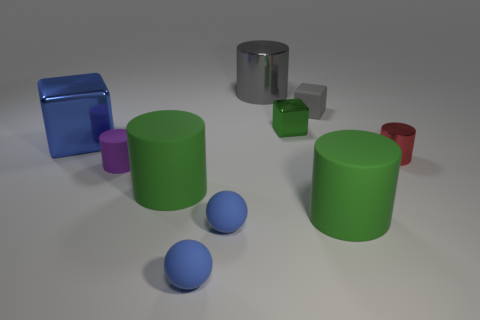Is there a large cylinder made of the same material as the tiny gray block?
Give a very brief answer. Yes. What number of objects are to the left of the red cylinder and in front of the large block?
Offer a terse response. 5. There is a tiny cylinder left of the red metal cylinder; what is its material?
Provide a succinct answer. Rubber. What is the size of the green block that is the same material as the large blue cube?
Offer a very short reply. Small. There is a blue block; are there any small blocks behind it?
Your response must be concise. Yes. What size is the other shiny thing that is the same shape as the small green thing?
Your response must be concise. Large. Is the color of the large shiny cylinder the same as the metallic cube that is on the left side of the purple matte cylinder?
Ensure brevity in your answer.  No. Is the color of the tiny rubber block the same as the big metallic cylinder?
Ensure brevity in your answer.  Yes. Are there fewer large shiny blocks than large yellow rubber things?
Your answer should be very brief. No. What number of other objects are there of the same color as the big block?
Your answer should be compact. 2. 